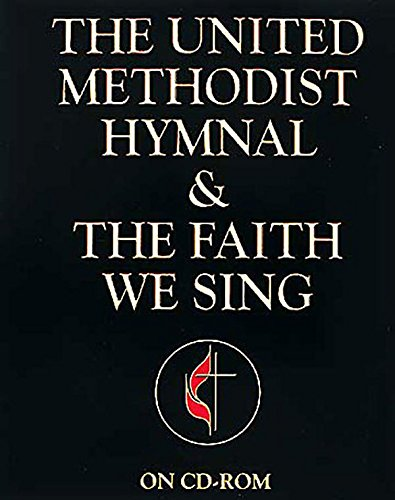Is this a fitness book? No, it is not a fitness book. Instead, it is a Christian hymnal used for religious and spiritual reflection during church services. 